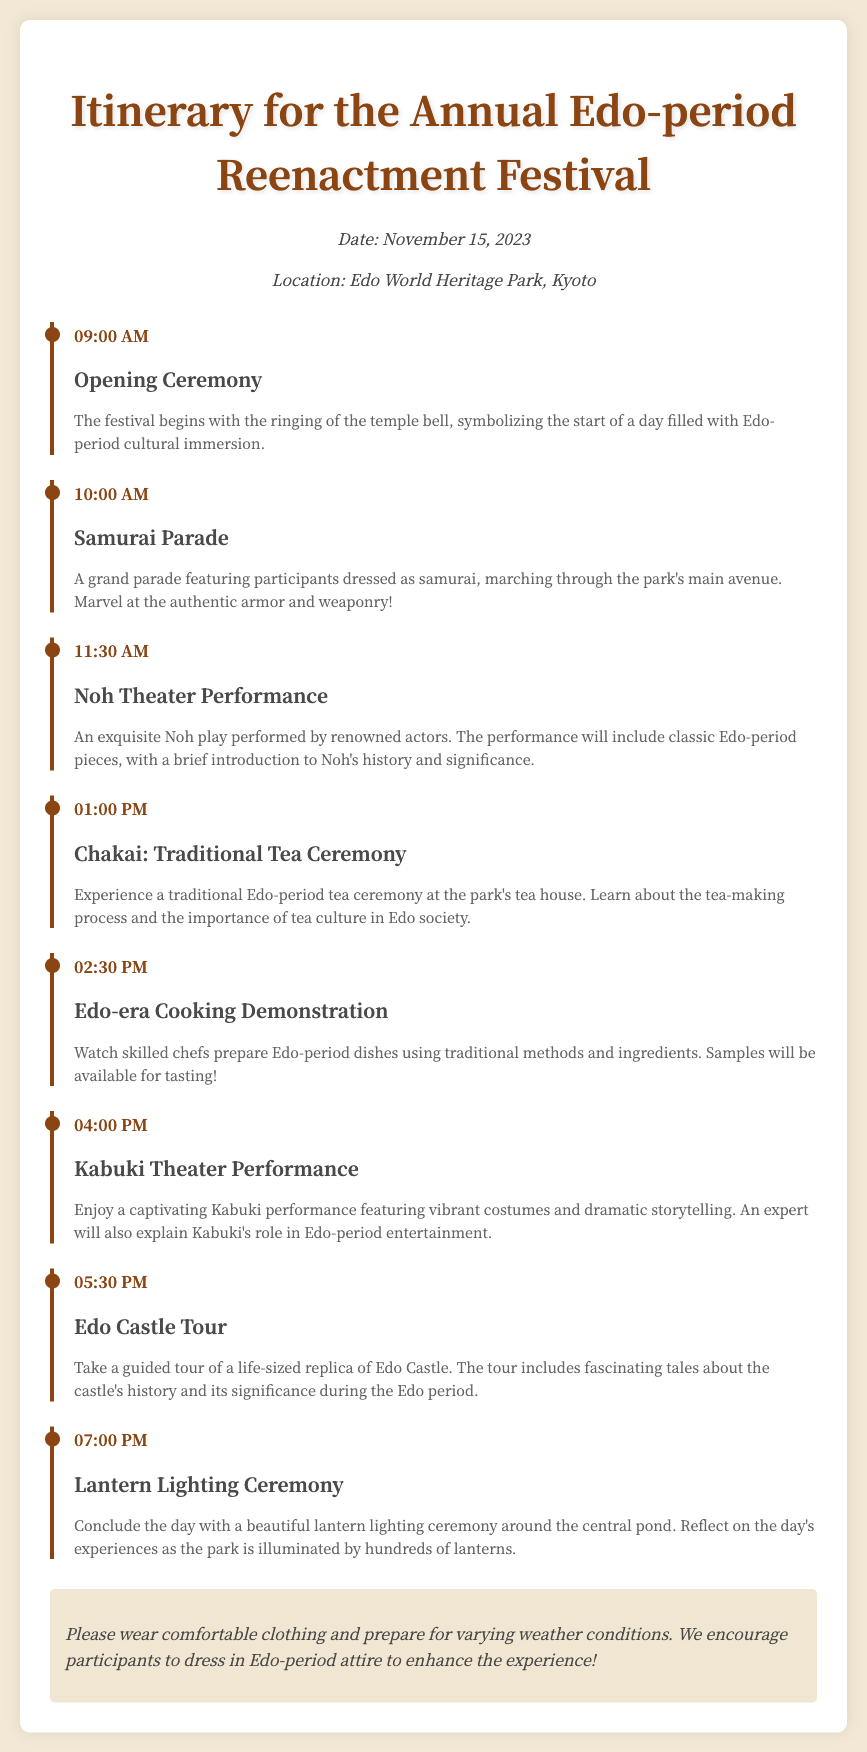What is the date of the festival? The festival is scheduled for November 15, 2023, as mentioned in the document.
Answer: November 15, 2023 What is the location of the festival? The location specified in the document is Edo World Heritage Park, Kyoto.
Answer: Edo World Heritage Park, Kyoto What time does the Opening Ceremony start? The document states that the Opening Ceremony begins at 09:00 AM.
Answer: 09:00 AM How many events are there in total? By counting the events listed in the document, there are a total of seven events scheduled for the day.
Answer: Seven What is the main focus of the Edo-era Cooking Demonstration? The demonstration is centered around watching chefs prepare Edo-period dishes using traditional methods and ingredients.
Answer: Edo-period dishes What is a unique activity participants can engage in during the festival? Participants are encouraged to dress in Edo-period attire to enhance the experience, as highlighted in the notes section.
Answer: Dress in Edo-period attire What performance is scheduled prior to lunch? The Noh Theater Performance is the event that takes place before lunch at 11:30 AM.
Answer: Noh Theater Performance What happens at 07:00 PM during the festival? The document indicates that a Lantern Lighting Ceremony takes place at this time, concluding the day's events.
Answer: Lantern Lighting Ceremony 